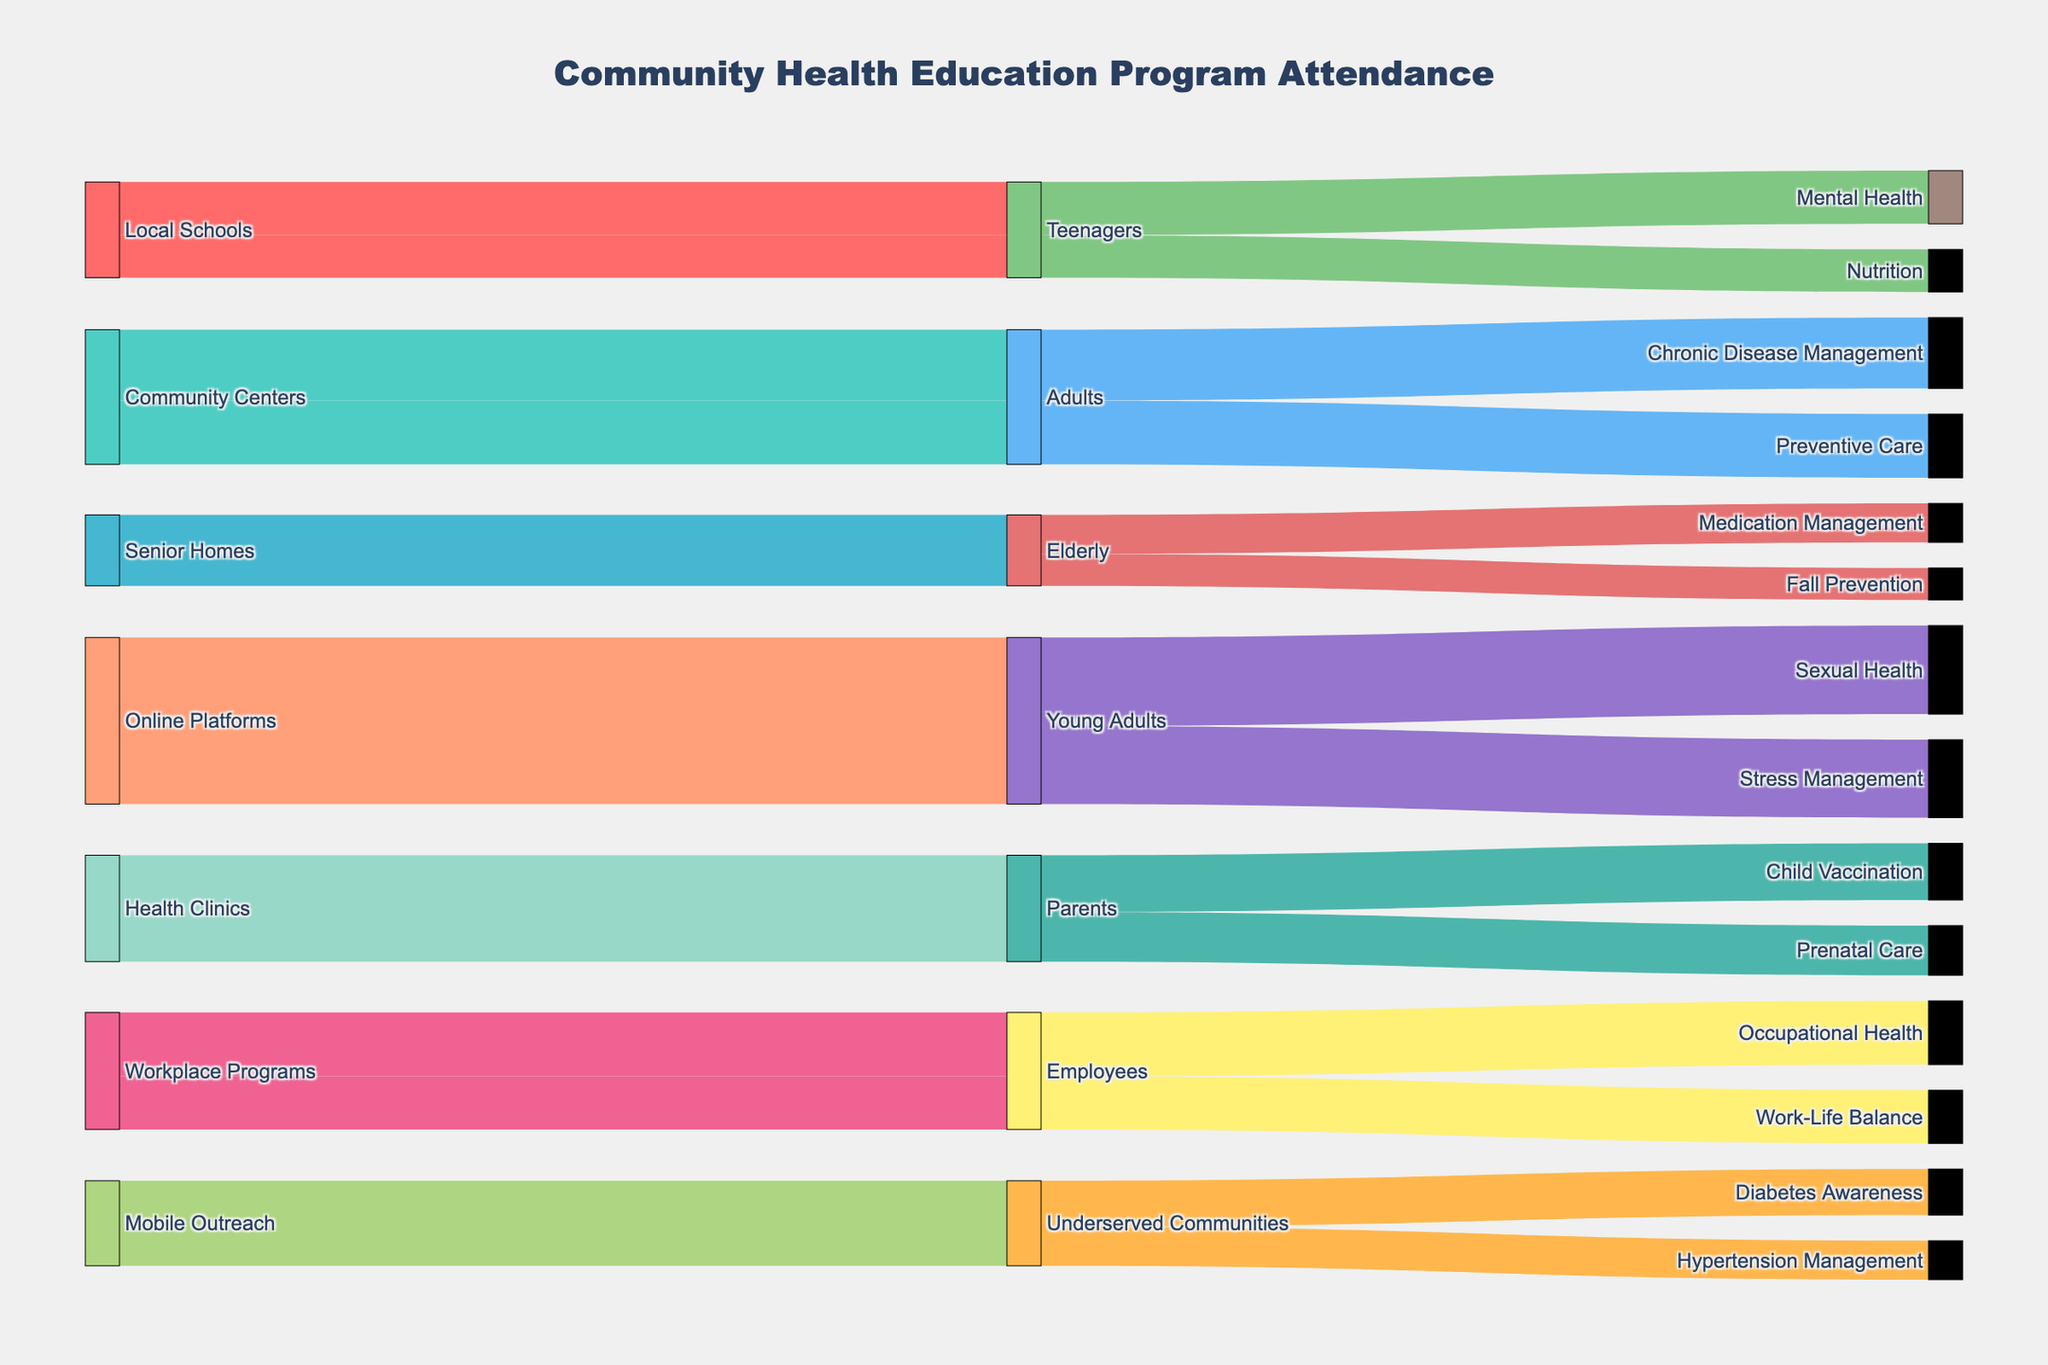How many attendees were there from Local Schools for Nutrition? Look at the Local Schools source and the Nutrition topic, the number of attendees is given.
Answer: 120 Which demographic group had the highest attendance for Stress Management? Find the Stress Management topic and trace it to the corresponding demographic group.
Answer: Young Adults What is the total number of attendees at Community Centers? Add the number of attendees for all topics under the Community Centers source. 200 + 180 = 380
Answer: 380 Compare the attendance for Fall Prevention and Medication Management among the elderly. Which topic had higher attendance? Compare the attendees listed under the Senior Homes source for Fall Prevention and Medication Management. 90 < 110
Answer: Medication Management Which source had the fewest total attendees? Sum the attendees for each source and identify the source with the smallest total. Local Schools: 150 + 120 = 270, Community Centers: 200 + 180 = 380, Senior Homes: 90 + 110 = 200, etc.
Answer: Senior Homes How does attendance for Mental Health among teenagers compare to that of Chronic Disease Management among adults? Look at the numbers for Mental Health under Teenagers and Chronic Disease Management under Adults and compare them. 150 vs 200
Answer: Chronic Disease Management among adults has higher attendance What is the average attendance for topics covered by health clinics? Take the sum of the attendees for Child Vaccination and Prenatal Care and divide by 2. (160 + 140) / 2 = 150
Answer: 150 Which topic under the Workplace Programs had higher attendance, Occupational Health or Work-Life Balance? Compare the attendees for Occupational Health and Work-Life Balance under the Workplace Programs source. 180 > 150
Answer: Occupational Health What's the total attendance for all health topics covered by Online Platforms? Sum the attendees for all topics under the Online Platforms source. 250 + 220 = 470
Answer: 470 How does the attendance for Preventive Care among adults compare to Diabetes Awareness in underserved communities? Look at the attendees for Preventive Care among adults and Diabetes Awareness in underserved communities and compare them. 180 vs 130
Answer: Preventive Care among adults has higher attendance 